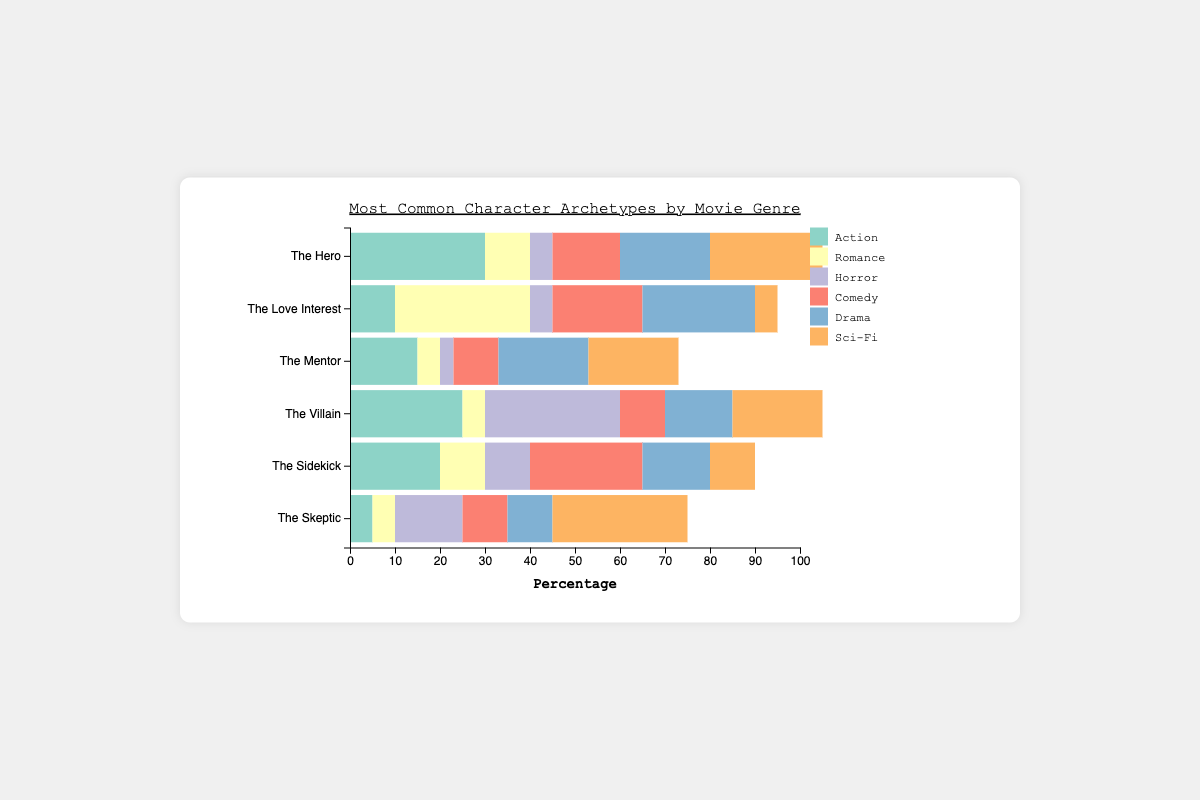Which character archetype is the most common in Action movies? The Hero is the most common archetype in Action movies as its bar segment is the longest within the Action genre.
Answer: The Hero Which genre features "The Skeptic" archetype the most? Sci-Fi features "The Skeptic" archetype the most as the segment for Sci-Fi is the longest in the "The Skeptic" bar.
Answer: Sci-Fi What is the total percentage of "The Mentor" archetype across all genres? Sum the values of "The Mentor" archetype for each genre: 15 (Action) + 5 (Romance) + 3 (Horror) + 10 (Comedy) + 20 (Drama) + 20 (Sci-Fi) = 73.
Answer: 73 In which genre is "The Villain" archetype more common than "The Hero"? Compare the segments of "The Villain" and "The Hero" within each genre. "The Villain" is more common than "The Hero" in the Horror genre (30 vs. 5).
Answer: Horror How much larger is the percentage of "The Sidekick" archetype in Comedy compared to Horror? Subtract the percentage of "The Sidekick" in Horror from Comedy: 25 (Comedy) - 10 (Horror) = 15.
Answer: 15 Which character archetype has the smallest percentage in the Romance genre? The Mentor and The Skeptic both have the smallest percentage in Romance as their segments are equally the shortest, both at 5%.
Answer: The Mentor, The Skeptic Which genre has the least percentage of "The Love Interest" archetype? Sci-Fi has the least percentage of "The Love Interest" as its segment is the shortest, at 5%.
Answer: Sci-Fi How does the percentage of "The Hero" differ between Sci-Fi and Romance genres? Subtract the percentage of "The Hero" in Romance from Sci-Fi: 25 (Sci-Fi) - 10 (Romance) = 15.
Answer: 15 Which genre has the widest range in the percentage values of character archetypes? Analyze the range (max - min) of each genre: Horror ranges from 3 (The Mentor) to 30 (The Villain) = 27, which is the widest.
Answer: Horror 